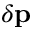Convert formula to latex. <formula><loc_0><loc_0><loc_500><loc_500>\delta p</formula> 